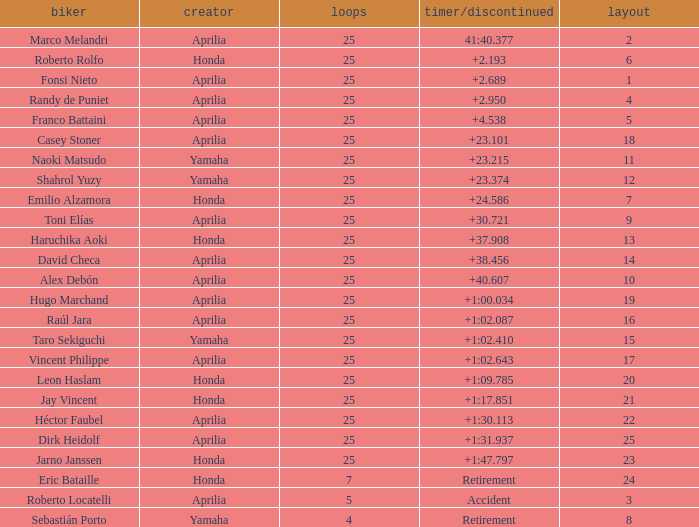Which Laps have a Time/Retired of +23.215, and a Grid larger than 11? None. Parse the table in full. {'header': ['biker', 'creator', 'loops', 'timer/discontinued', 'layout'], 'rows': [['Marco Melandri', 'Aprilia', '25', '41:40.377', '2'], ['Roberto Rolfo', 'Honda', '25', '+2.193', '6'], ['Fonsi Nieto', 'Aprilia', '25', '+2.689', '1'], ['Randy de Puniet', 'Aprilia', '25', '+2.950', '4'], ['Franco Battaini', 'Aprilia', '25', '+4.538', '5'], ['Casey Stoner', 'Aprilia', '25', '+23.101', '18'], ['Naoki Matsudo', 'Yamaha', '25', '+23.215', '11'], ['Shahrol Yuzy', 'Yamaha', '25', '+23.374', '12'], ['Emilio Alzamora', 'Honda', '25', '+24.586', '7'], ['Toni Elías', 'Aprilia', '25', '+30.721', '9'], ['Haruchika Aoki', 'Honda', '25', '+37.908', '13'], ['David Checa', 'Aprilia', '25', '+38.456', '14'], ['Alex Debón', 'Aprilia', '25', '+40.607', '10'], ['Hugo Marchand', 'Aprilia', '25', '+1:00.034', '19'], ['Raúl Jara', 'Aprilia', '25', '+1:02.087', '16'], ['Taro Sekiguchi', 'Yamaha', '25', '+1:02.410', '15'], ['Vincent Philippe', 'Aprilia', '25', '+1:02.643', '17'], ['Leon Haslam', 'Honda', '25', '+1:09.785', '20'], ['Jay Vincent', 'Honda', '25', '+1:17.851', '21'], ['Héctor Faubel', 'Aprilia', '25', '+1:30.113', '22'], ['Dirk Heidolf', 'Aprilia', '25', '+1:31.937', '25'], ['Jarno Janssen', 'Honda', '25', '+1:47.797', '23'], ['Eric Bataille', 'Honda', '7', 'Retirement', '24'], ['Roberto Locatelli', 'Aprilia', '5', 'Accident', '3'], ['Sebastián Porto', 'Yamaha', '4', 'Retirement', '8']]} 